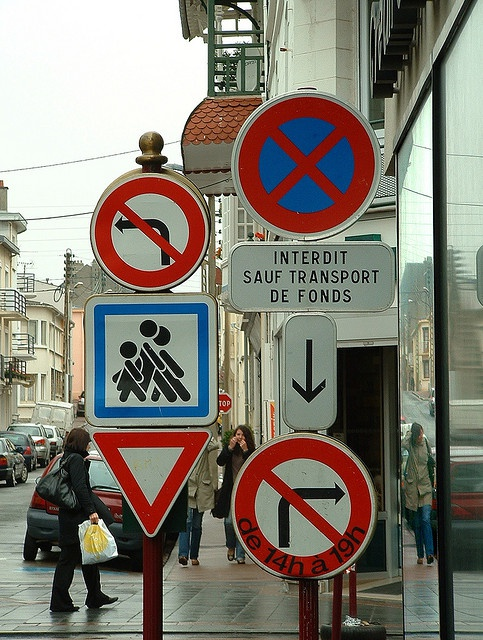Describe the objects in this image and their specific colors. I can see people in white, black, gray, and maroon tones, car in white, black, darkgray, maroon, and gray tones, car in white, black, maroon, gray, and teal tones, people in white, black, gray, and darkgreen tones, and people in white, black, gray, darkgreen, and darkgray tones in this image. 